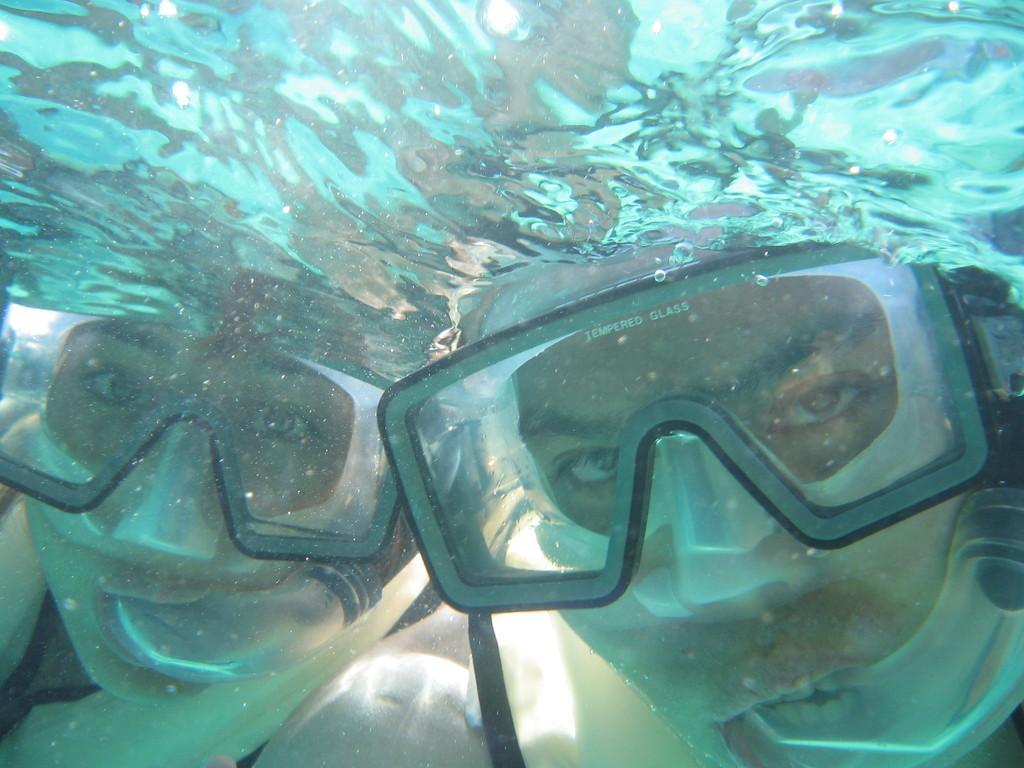Can you describe this image briefly? In this picture I can see two persons under water. I can see swimming goggles. 